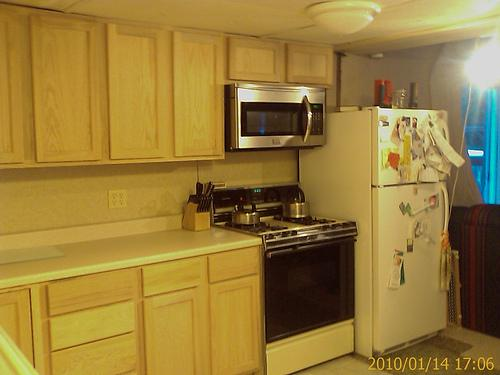What household food might you find in the object on the right? Please explain your reasoning. milk. The object on the right is a refrigerator. tinned fruits, peanuts, and potato chips are not refrigerated. 